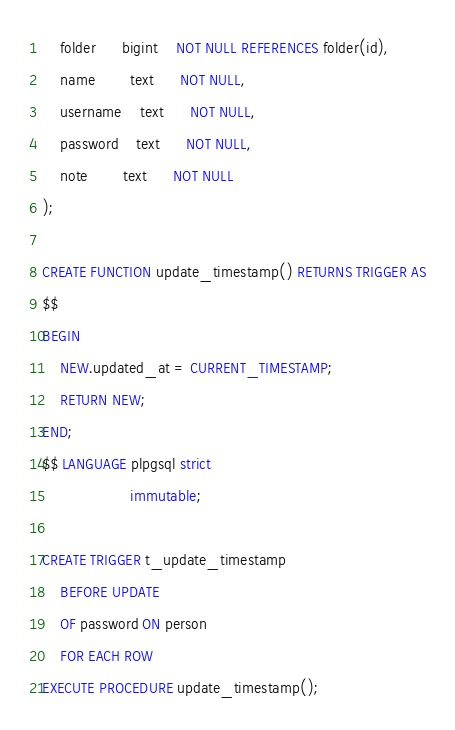Convert code to text. <code><loc_0><loc_0><loc_500><loc_500><_SQL_>    folder      bigint    NOT NULL REFERENCES folder(id),
    name        text      NOT NULL,
    username    text      NOT NULL,
    password    text      NOT NULL,
    note        text      NOT NULL
);

CREATE FUNCTION update_timestamp() RETURNS TRIGGER AS
$$
BEGIN
    NEW.updated_at = CURRENT_TIMESTAMP;
    RETURN NEW;
END;
$$ LANGUAGE plpgsql strict
                    immutable;

CREATE TRIGGER t_update_timestamp
    BEFORE UPDATE
    OF password ON person
    FOR EACH ROW
EXECUTE PROCEDURE update_timestamp();
</code> 